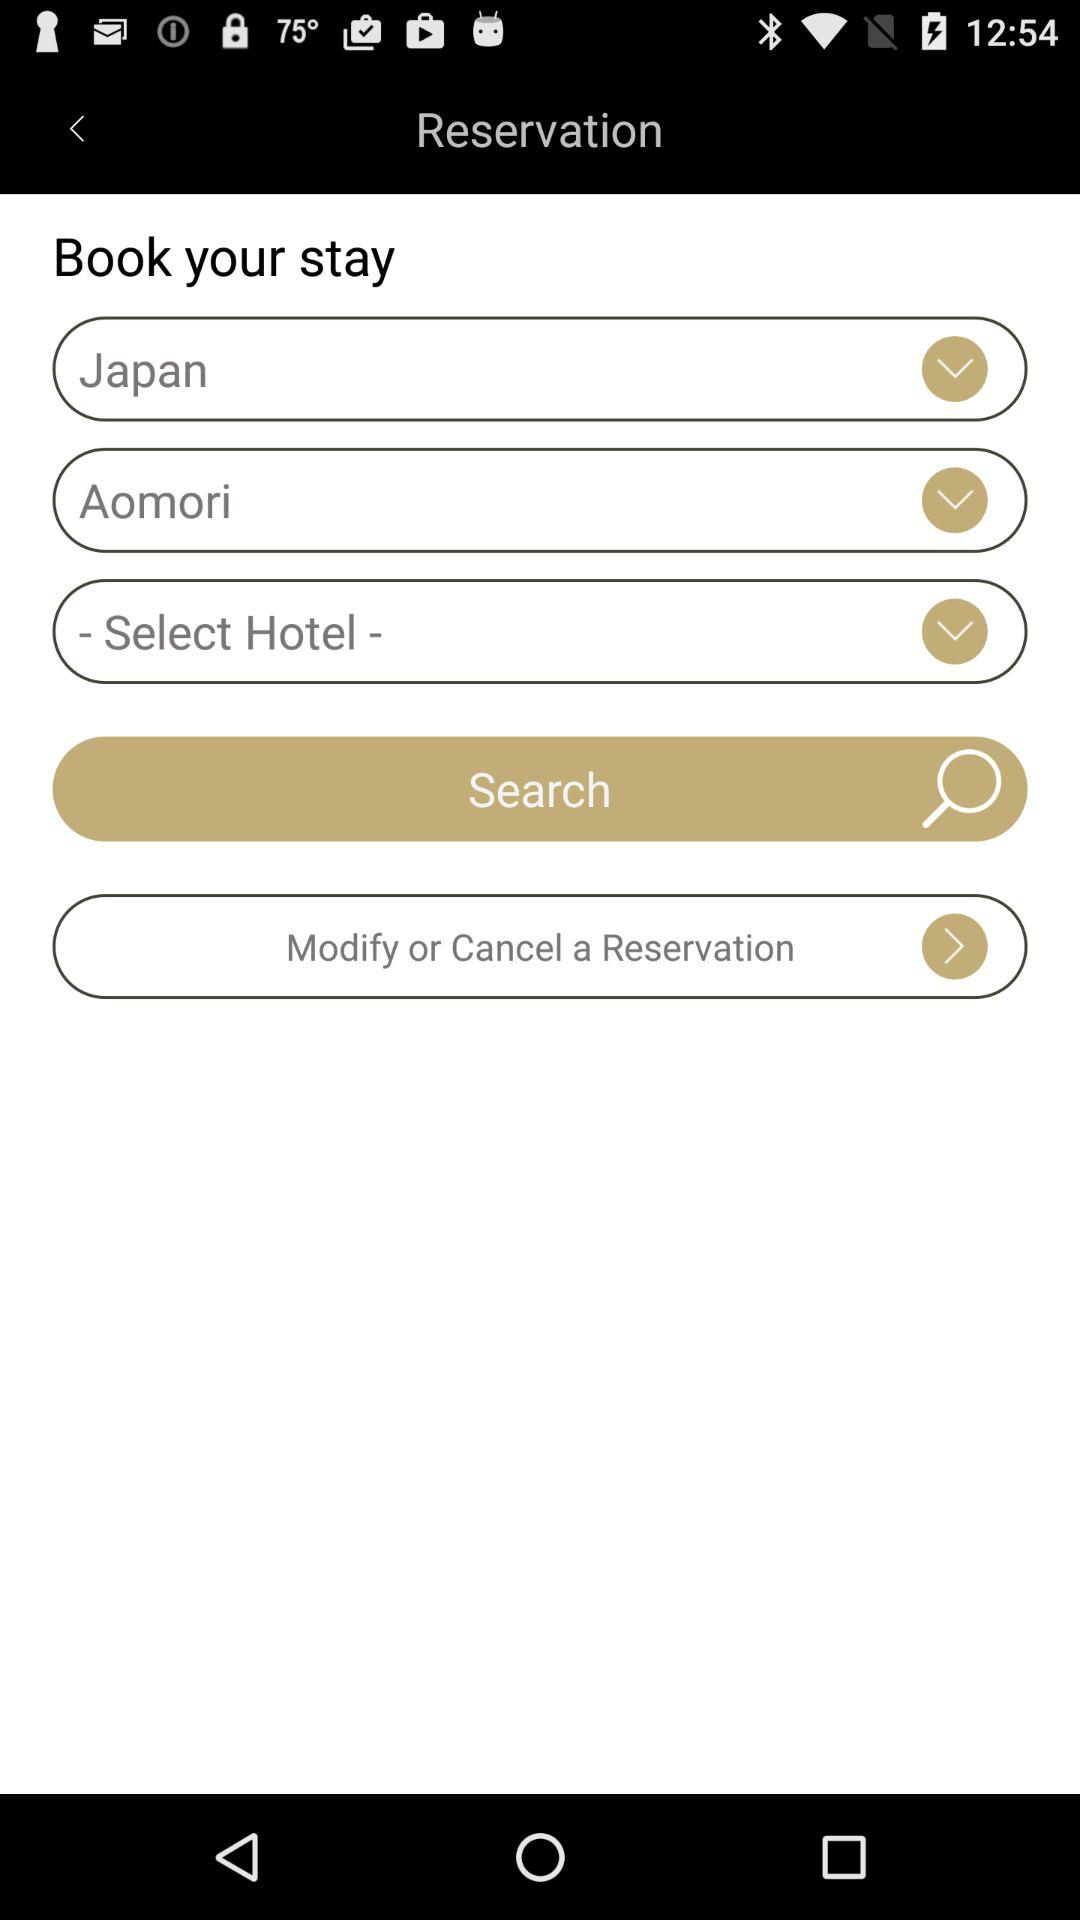What is the selected country? The selected country is Japan. 